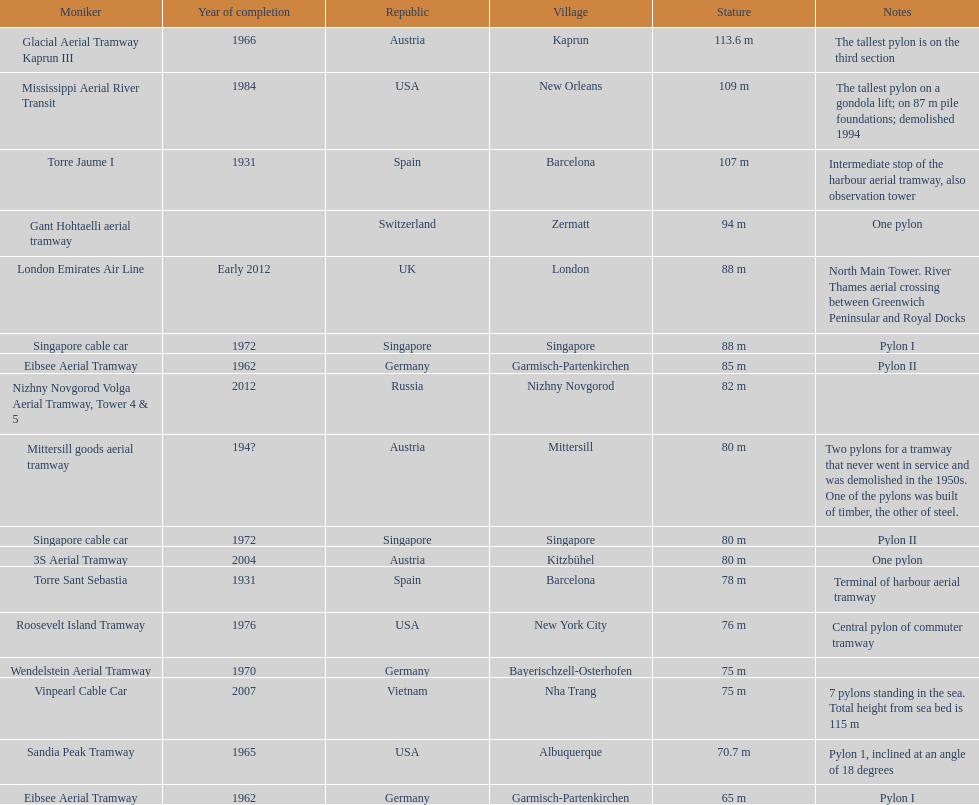How many metres is the tallest pylon? 113.6 m. 